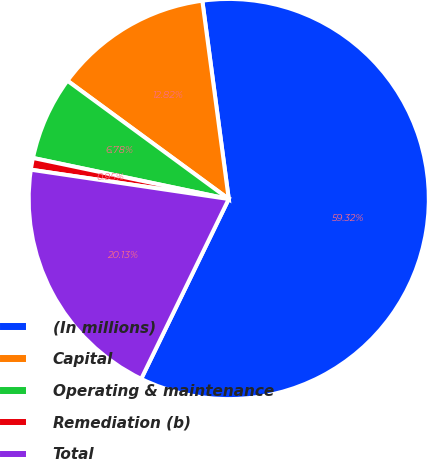Convert chart. <chart><loc_0><loc_0><loc_500><loc_500><pie_chart><fcel>(In millions)<fcel>Capital<fcel>Operating & maintenance<fcel>Remediation (b)<fcel>Total<nl><fcel>59.32%<fcel>12.82%<fcel>6.78%<fcel>0.95%<fcel>20.13%<nl></chart> 